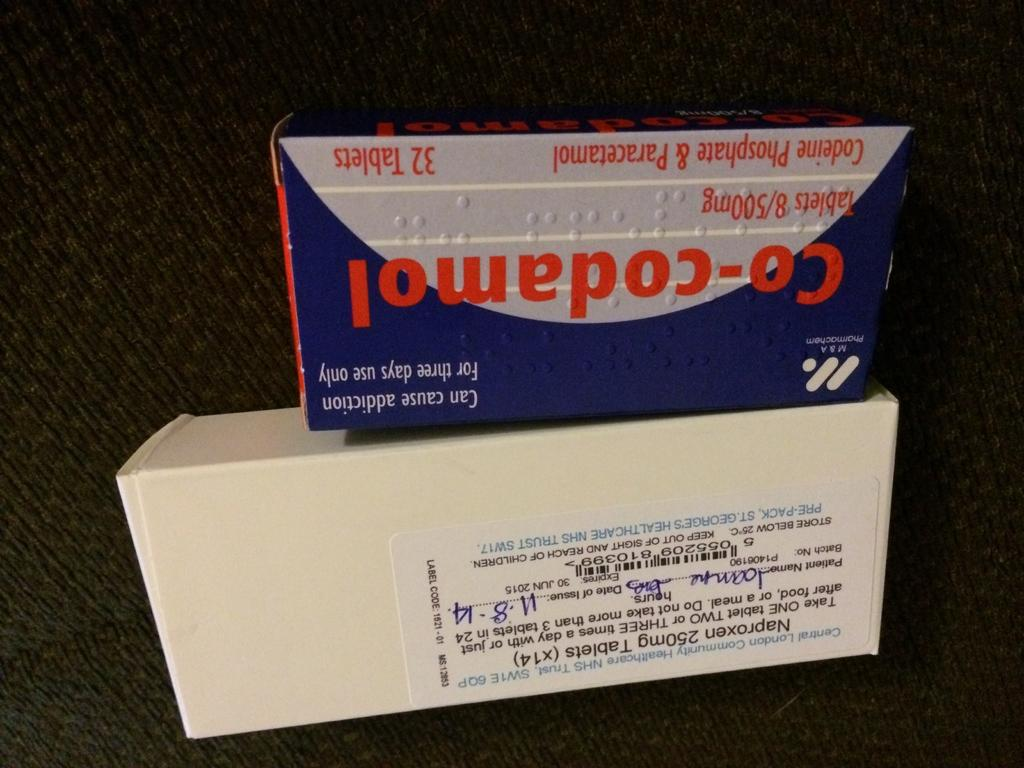<image>
Give a short and clear explanation of the subsequent image. A box of Naproxen and Co-Codamel tablets issued on 11-8-14. 